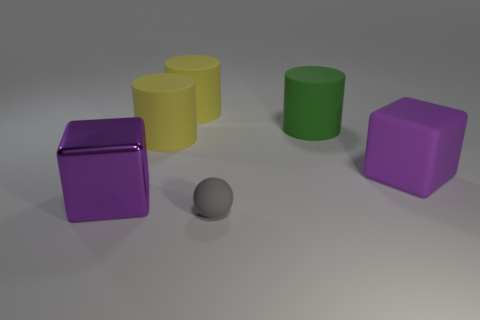The object that is in front of the purple rubber thing and behind the tiny matte thing is what color?
Your answer should be compact. Purple. How many other things are the same color as the matte cube?
Your answer should be very brief. 1. There is a purple cube that is right of the purple cube that is to the left of the small gray matte thing on the right side of the purple metal cube; what is its material?
Your answer should be very brief. Rubber. What number of spheres are yellow matte things or metal objects?
Offer a terse response. 0. Are there any other things that have the same size as the purple metal thing?
Provide a short and direct response. Yes. There is a big purple cube that is in front of the large purple object that is right of the tiny matte object; how many large yellow cylinders are left of it?
Your answer should be very brief. 0. Does the small gray thing have the same shape as the large purple rubber thing?
Your answer should be very brief. No. Do the big purple block behind the metallic thing and the cylinder that is on the right side of the gray object have the same material?
Make the answer very short. Yes. What number of things are cylinders on the right side of the tiny ball or big cubes that are behind the big purple metal block?
Keep it short and to the point. 2. Is there any other thing that is the same shape as the gray object?
Give a very brief answer. No. 